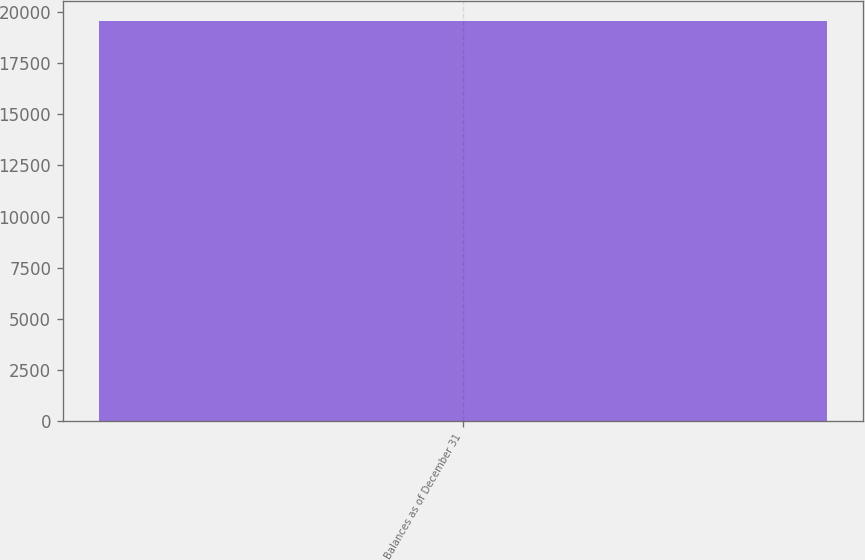Convert chart. <chart><loc_0><loc_0><loc_500><loc_500><bar_chart><fcel>Balances as of December 31<nl><fcel>19582<nl></chart> 